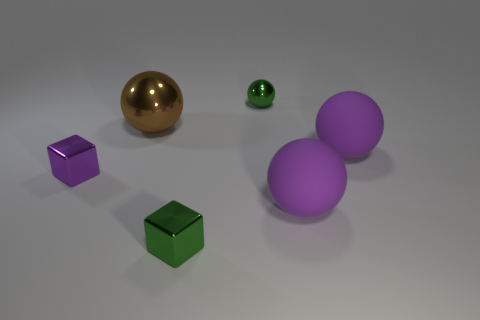Is the number of brown balls on the left side of the tiny purple shiny block less than the number of tiny green cubes?
Your response must be concise. Yes. There is a big rubber object that is in front of the small purple object; what is its color?
Offer a very short reply. Purple. There is a cube that is the same color as the tiny shiny ball; what is it made of?
Make the answer very short. Metal. Is there a purple rubber thing that has the same shape as the big metal thing?
Keep it short and to the point. Yes. How many other objects have the same shape as the big metal object?
Ensure brevity in your answer.  3. Do the tiny ball and the large metal ball have the same color?
Give a very brief answer. No. Is the number of tiny matte blocks less than the number of tiny green metal balls?
Your answer should be very brief. Yes. There is a tiny green object that is behind the small purple thing; what is its material?
Your answer should be compact. Metal. What material is the other cube that is the same size as the green metal block?
Keep it short and to the point. Metal. There is a small cube right of the large sphere that is to the left of the small green metallic thing in front of the small green metallic sphere; what is its material?
Offer a very short reply. Metal. 